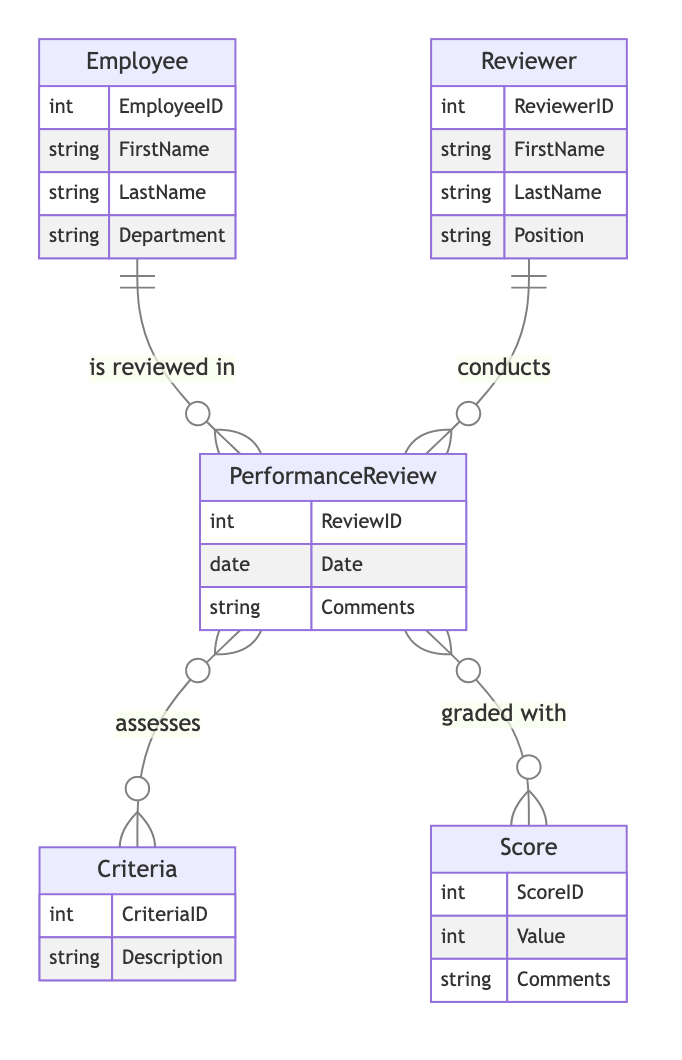What is the primary relationship between Reviewer and PerformanceReview? The primary relationship between Reviewer and PerformanceReview is "conducts," which indicates that a Reviewer is responsible for conducting multiple Performance Reviews. This is shown by the "1:N" cardinality noted in the diagram.
Answer: conducts How many attributes are associated with the Employee entity? The Employee entity has four attributes listed: EmployeeID, FirstName, LastName, and Department. By counting these attributes, we can confirm the number.
Answer: 4 What is the cardinality of the relationship between PerformanceReview and Score? The relationship between PerformanceReview and Score is defined as "N:M," which means that each Performance Review can be associated with multiple Scores, and each Score can be linked to multiple Performance Reviews.
Answer: N:M Which entity is assessed in the PerformanceReview? The entity assessed in the PerformanceReview is Criteria, as indicated by the "assesses" relationship connecting these two entities. This implies that each Performance Review evaluates multiple Criteria.
Answer: Criteria What type of information is contained in the Score entity? The Score entity contains three attributes: ScoreID, Value, and Comments. These attributes describe the identification number for the score, the score value itself, and any comments related to the score.
Answer: ScoreID, Value, Comments How many entities are directly involved in the performance review process? In the diagram, there are five entities involved in the performance review process: Employee, Reviewer, PerformanceReview, Criteria, and Score. By counting these entities, we can confirm the number.
Answer: 5 What does the PerformanceReview entity represent? The PerformanceReview entity represents a specific instance of the evaluation process, containing details such as ReviewID, Date, and Comments about the review. Each instance reflects a particular Review conducted for an Employee.
Answer: Performance evaluation instance Who conducts the PerformanceReview? The Reviewer conducts the PerformanceReview, as indicated by the relationship labeled "conducts" in the diagram, which connects the Reviewer entity to the PerformanceReview entity.
Answer: Reviewer 